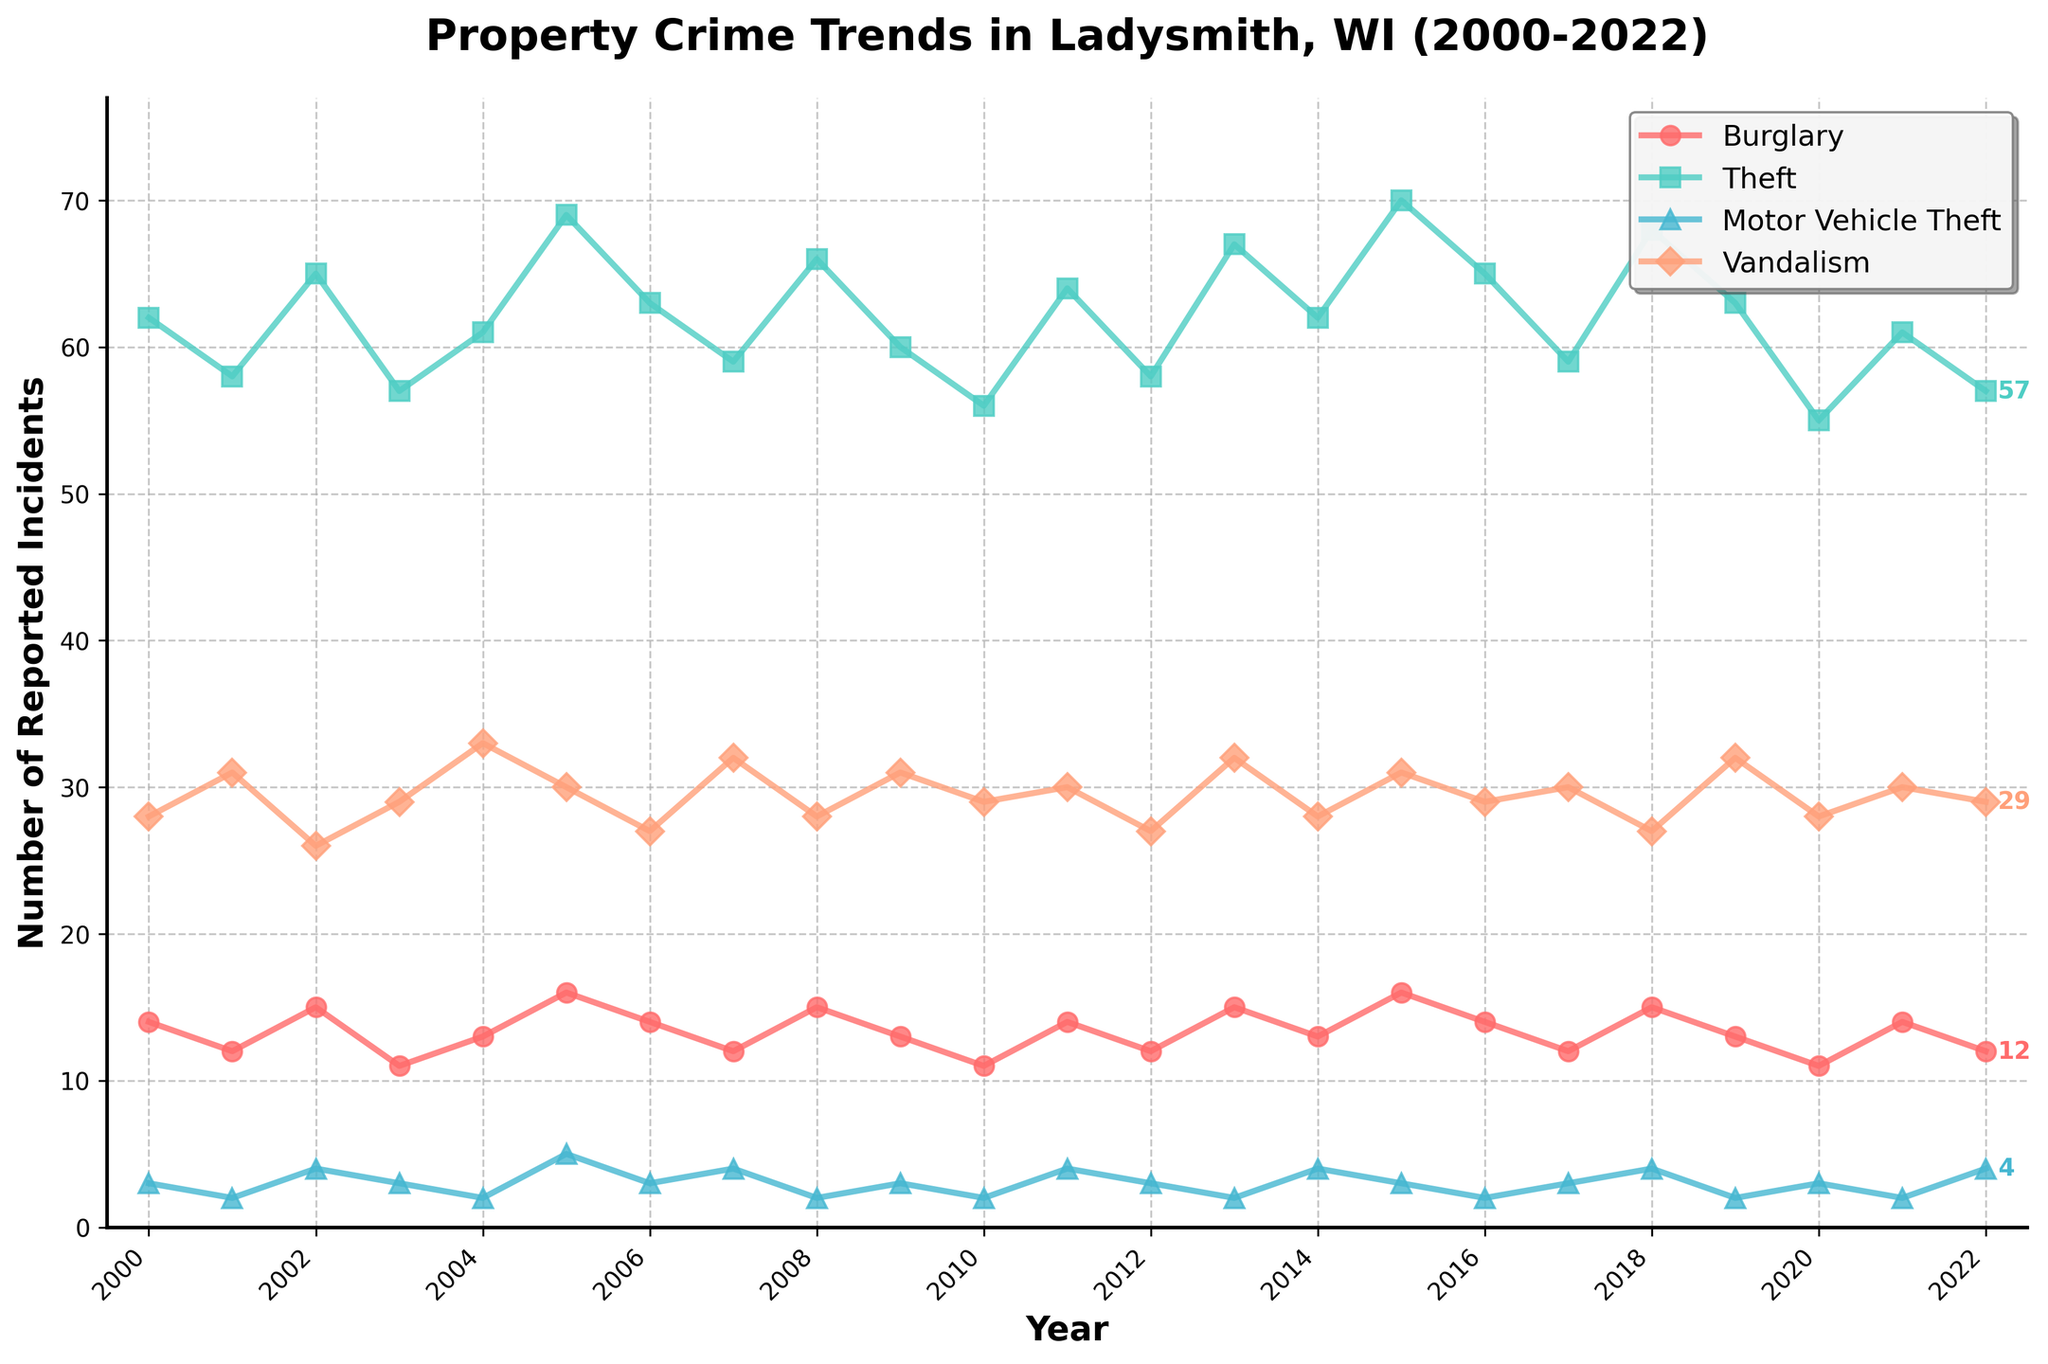What's the average number of Theft incidents reported between 2005 and 2010? To calculate the average number of Theft incidents from 2005 to 2010, sum the values for each year within this range and divide by the number of years: (69 + 63 + 59 + 66 + 60 + 56) / 6 = 373 / 6 = 62.17
Answer: 62.17 Which property crime has shown the most consistent trend over the years? By observing the lines, the Theft category appears to have the most consistent trend without significant fluctuations, maintaining a range between 55 and 70 incidents.
Answer: Theft In what year did Burglary incidents peak, and what was the value? The highest point in the Burglary line is in 2005, where 16 incidents were reported.
Answer: 2005, 16 Between 2007 and 2012, during which year were Vandalism incidents the lowest? Observing the Vandalism line between 2007 and 2012, the lowest value occurs in 2012 with 27 incidents.
Answer: 2012 How did the number of Motor Vehicle Theft incidents change from 2000 to 2022? Compare the first and last data points for Motor Vehicle Theft: 2000 had 3 incidents, and 2022 had 4 incidents, indicating a slight increase by 1 incident over the period.
Answer: Increased by 1 Comparing 2010 and 2020, which year had more total property crime incidents reported? Sum the incidents for each category in 2010 and 2020. For 2010: 11 (Burglary) + 56 (Theft) + 2 (Motor Vehicle Theft) + 29 (Vandalism) = 98. For 2020: 11 (Burglary) + 55 (Theft) + 3 (Motor Vehicle Theft) + 28 (Vandalism) = 97. Thus, 2010 had more incidents.
Answer: 2010 What trend can be observed in Burglary incidents over the entire period? The Burglary incidents show a relatively stable trend with some fluctuations but without a clear increasing or decreasing pattern, maintaining values mostly between 11 and 16.
Answer: Stable with fluctuations In which year were Theft incidents the lowest and what was the value? The lowest point in the Theft line is in 2020 with 55 incidents.
Answer: 2020, 55 Which crime type had the highest increase in incidents from the beginning to the end of the period? By comparing the first and last data points for each crime type, Theft shows the largest change. In 2000, there were 62 Theft incidents, and in 2022, there were 57, but this is actually a decrease. However, Vandalism started at 28 in 2000 and ended at 29 in 2022, showing the only increase among the categories.
Answer: Vandalism What is the combined number of Theft and Burglary incidents reported in 2008? Add the 2008 values for Theft and Burglary: 66 (Theft) + 15 (Burglary) = 81.
Answer: 81 